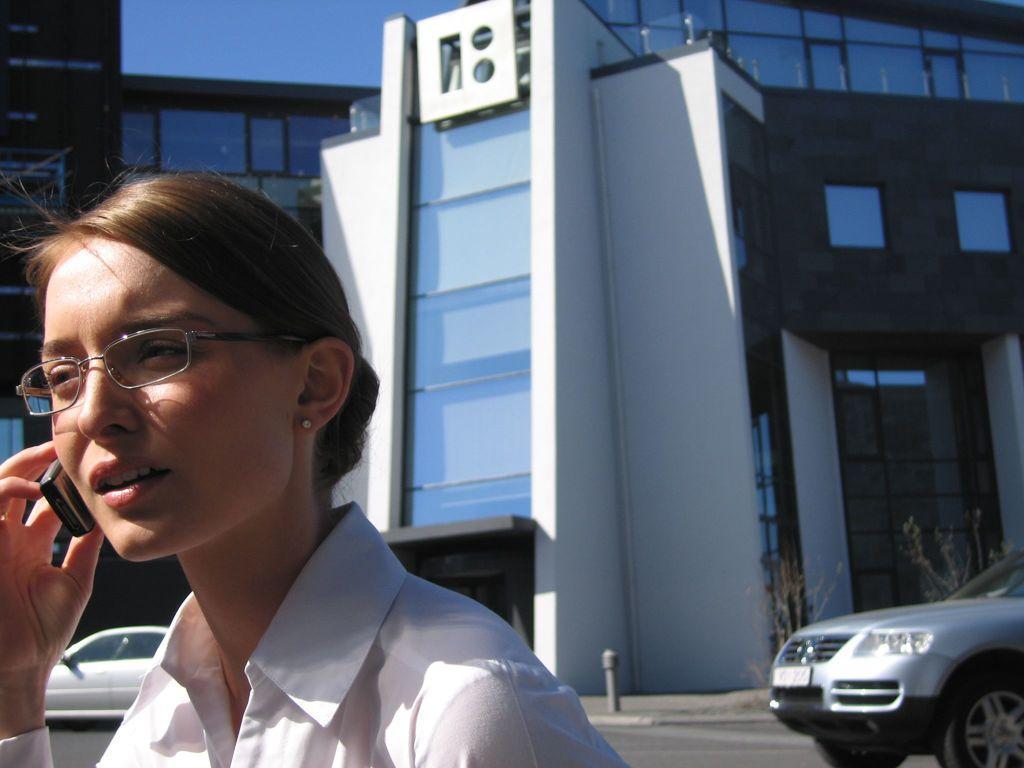How would you summarize this image in a sentence or two? In this picture we can see a woman, she wore spectacles and she is holding mobile, in the background we can see few cars and buildings. 